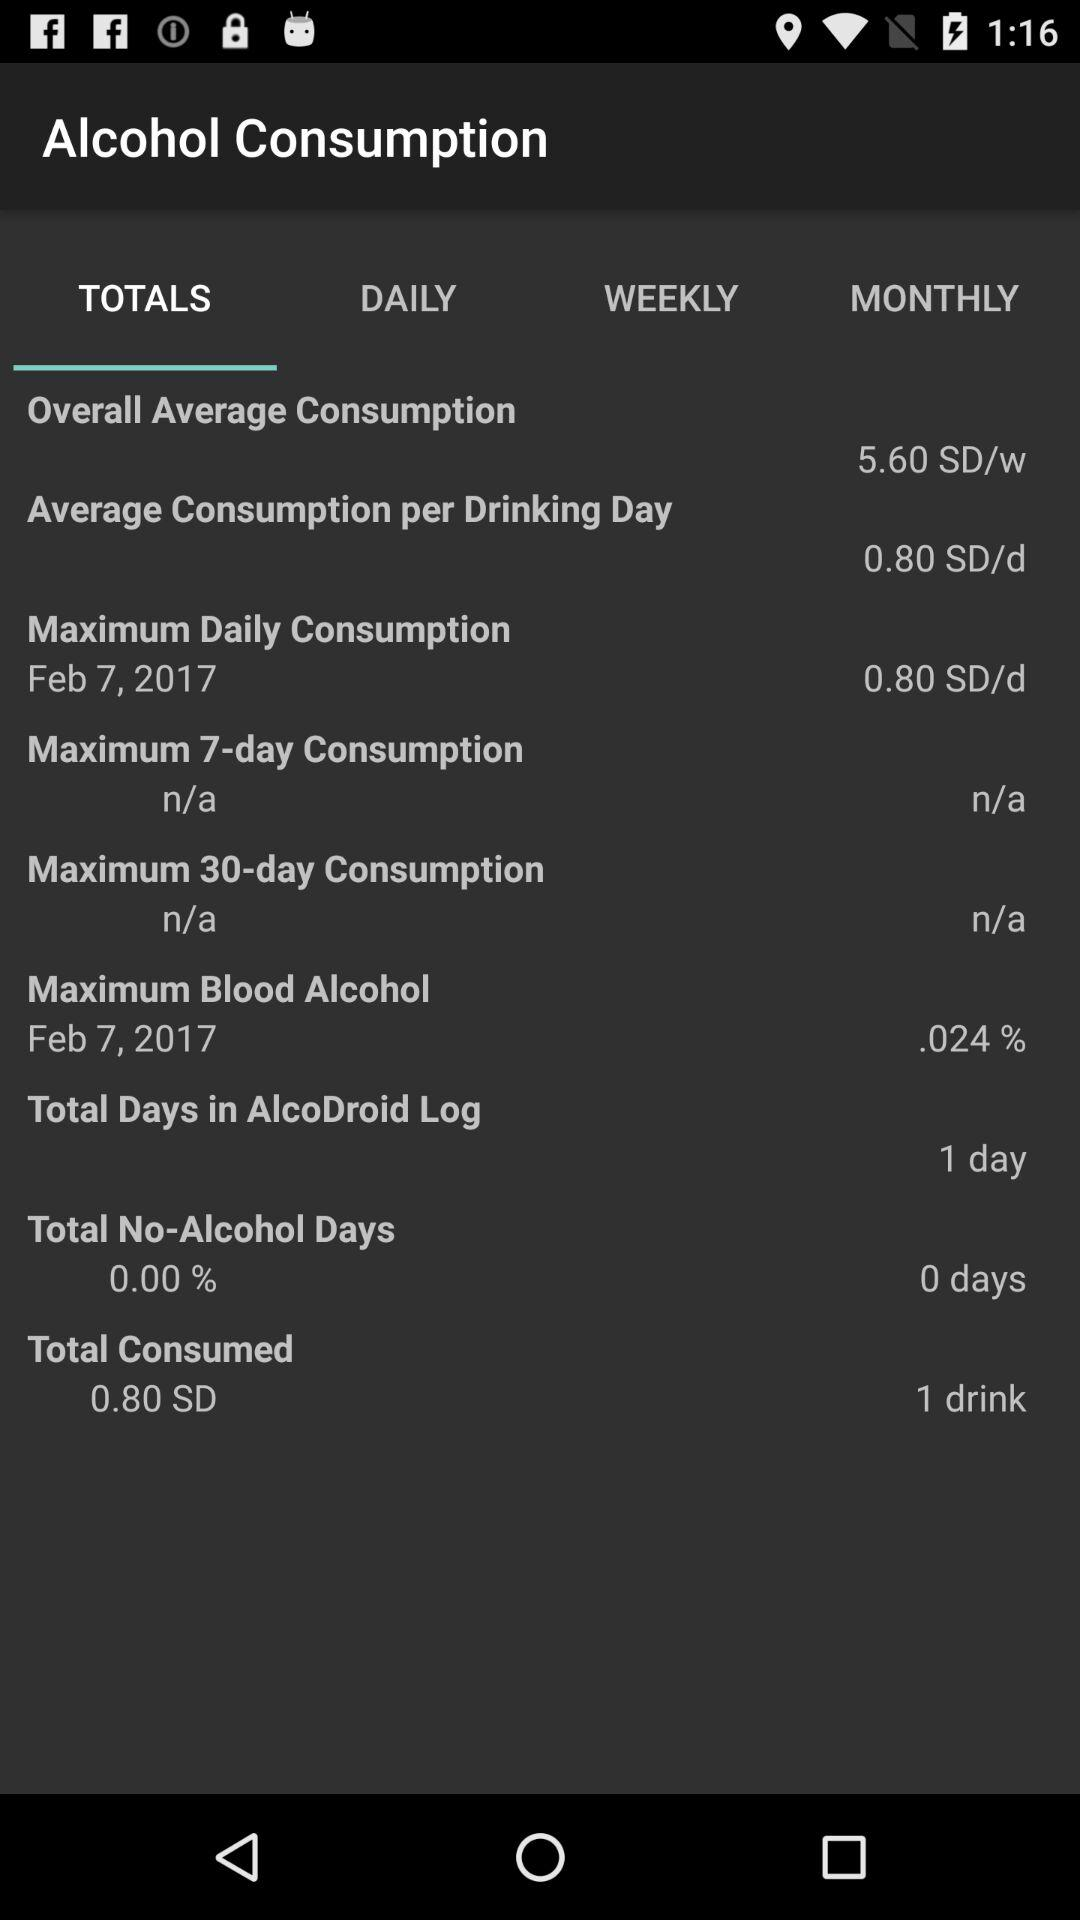What is the overall average consumption? The overall average consumption is 5.60 SD/w. 